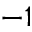Convert formula to latex. <formula><loc_0><loc_0><loc_500><loc_500>^ { - 1 }</formula> 